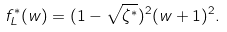<formula> <loc_0><loc_0><loc_500><loc_500>f _ { L } ^ { * } ( w ) = ( 1 - \sqrt { \zeta ^ { * } } ) ^ { 2 } ( w + 1 ) ^ { 2 } .</formula> 